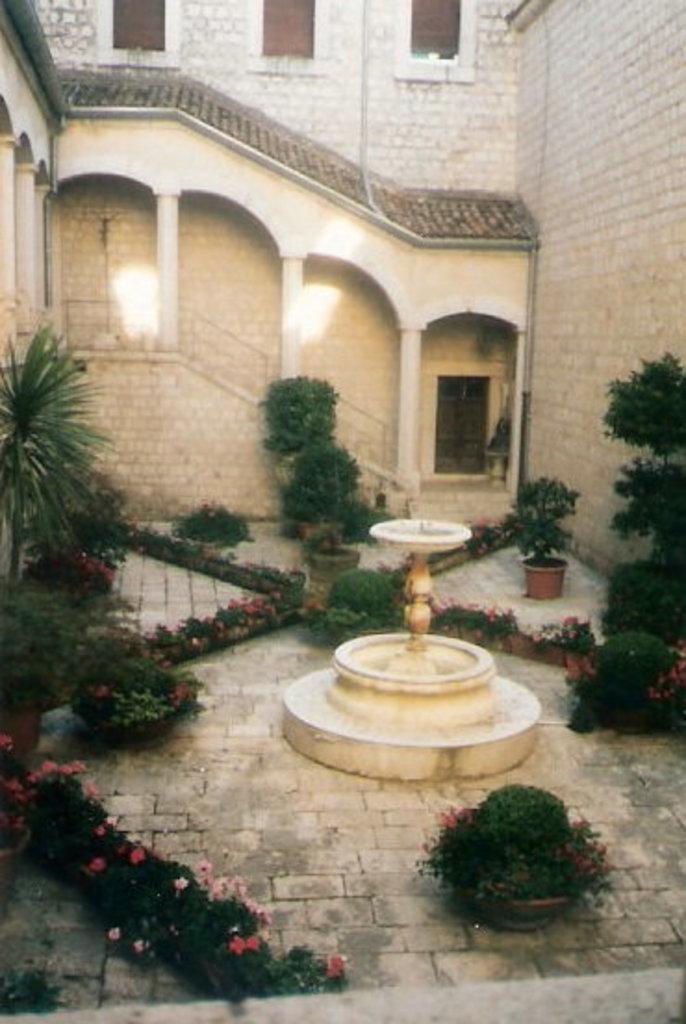How would you summarize this image in a sentence or two? In the center of the image, we can see a fountain and in the background, there are flower pots and plants and there is a building with stairs. 